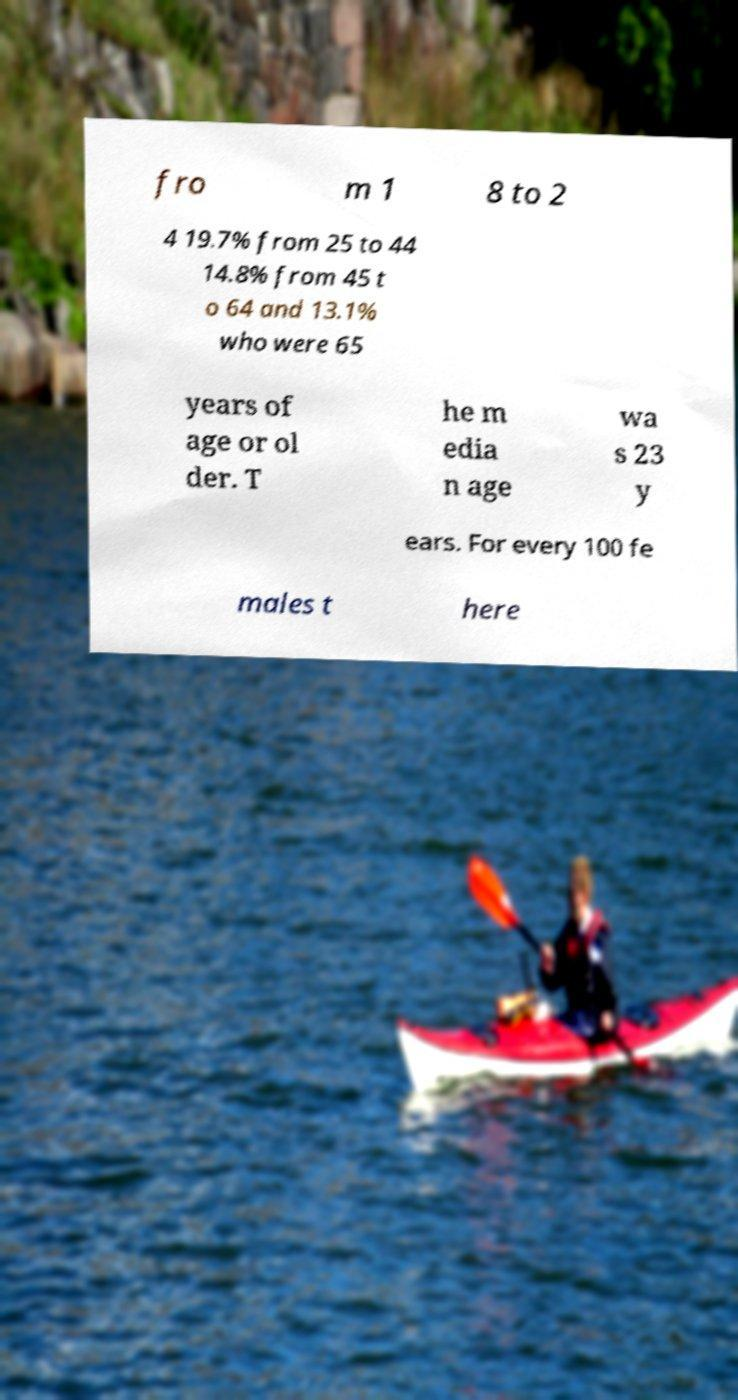Can you read and provide the text displayed in the image?This photo seems to have some interesting text. Can you extract and type it out for me? fro m 1 8 to 2 4 19.7% from 25 to 44 14.8% from 45 t o 64 and 13.1% who were 65 years of age or ol der. T he m edia n age wa s 23 y ears. For every 100 fe males t here 